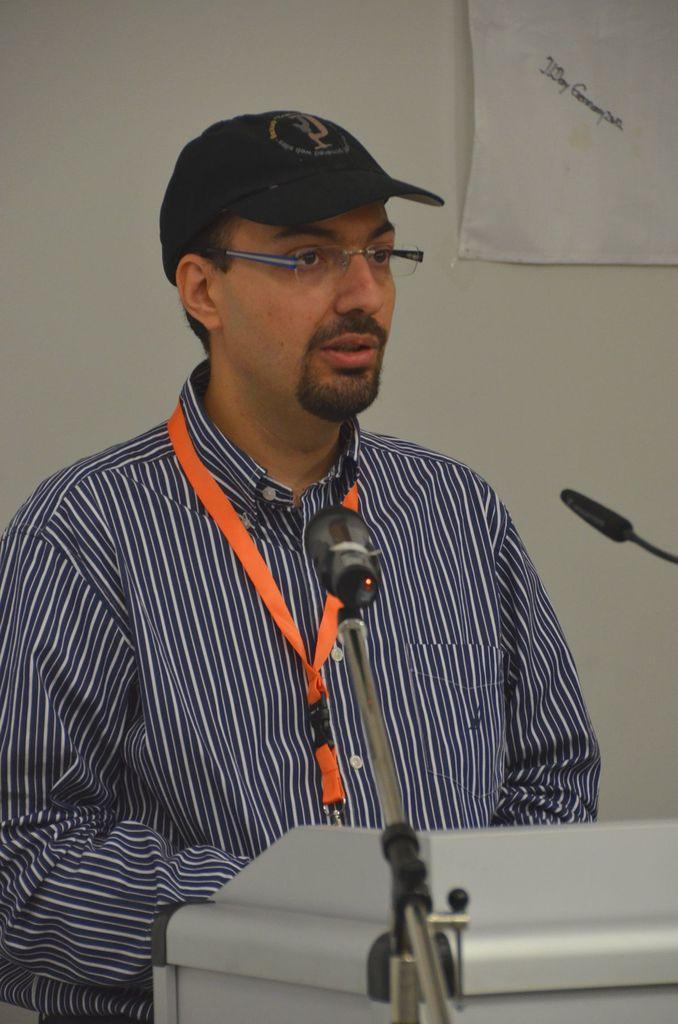In one or two sentences, can you explain what this image depicts? In this picture there is a man standing and wore spectacle, cap and tag, in front of him we can see microphone and podium. In the background of the image we can see a banner on the wall. 